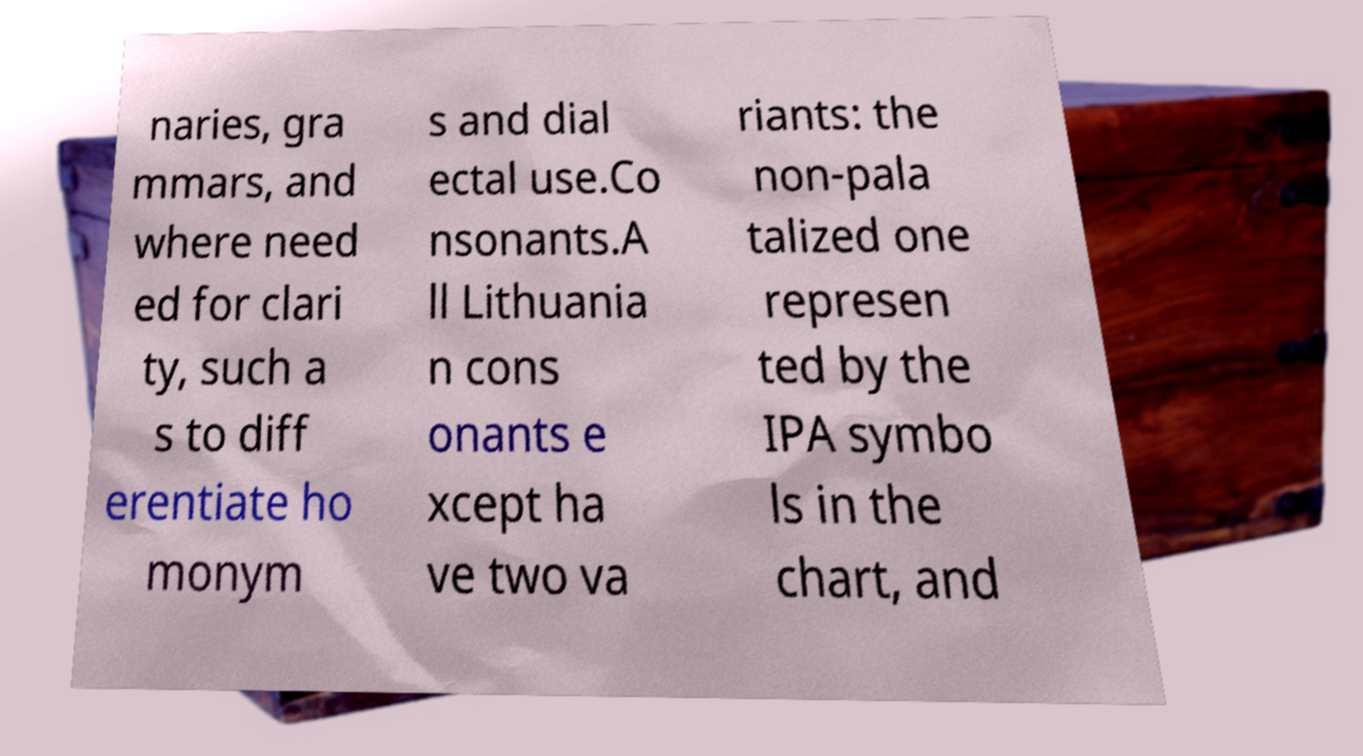Please read and relay the text visible in this image. What does it say? naries, gra mmars, and where need ed for clari ty, such a s to diff erentiate ho monym s and dial ectal use.Co nsonants.A ll Lithuania n cons onants e xcept ha ve two va riants: the non-pala talized one represen ted by the IPA symbo ls in the chart, and 